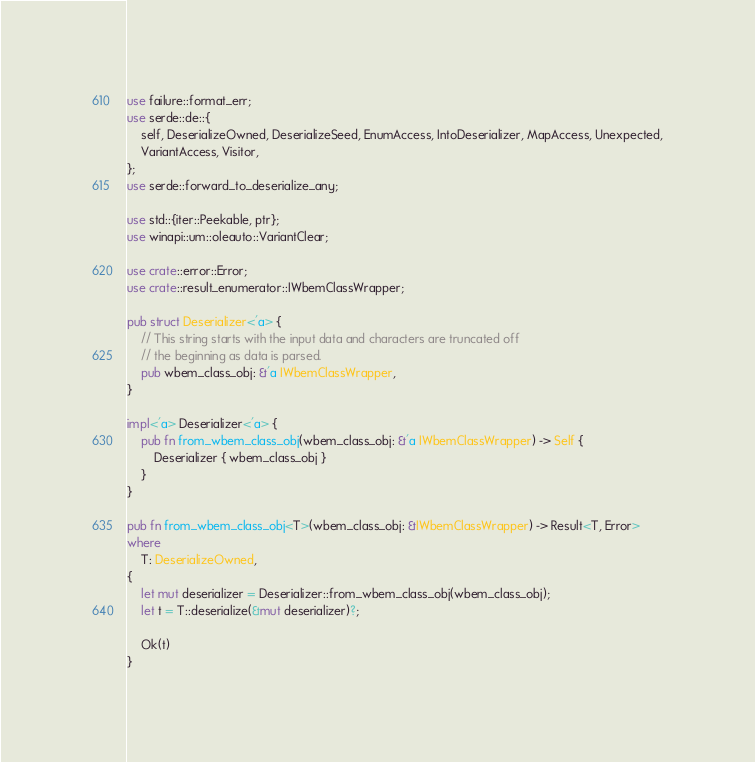<code> <loc_0><loc_0><loc_500><loc_500><_Rust_>use failure::format_err;
use serde::de::{
    self, DeserializeOwned, DeserializeSeed, EnumAccess, IntoDeserializer, MapAccess, Unexpected,
    VariantAccess, Visitor,
};
use serde::forward_to_deserialize_any;

use std::{iter::Peekable, ptr};
use winapi::um::oleauto::VariantClear;

use crate::error::Error;
use crate::result_enumerator::IWbemClassWrapper;

pub struct Deserializer<'a> {
    // This string starts with the input data and characters are truncated off
    // the beginning as data is parsed.
    pub wbem_class_obj: &'a IWbemClassWrapper,
}

impl<'a> Deserializer<'a> {
    pub fn from_wbem_class_obj(wbem_class_obj: &'a IWbemClassWrapper) -> Self {
        Deserializer { wbem_class_obj }
    }
}

pub fn from_wbem_class_obj<T>(wbem_class_obj: &IWbemClassWrapper) -> Result<T, Error>
where
    T: DeserializeOwned,
{
    let mut deserializer = Deserializer::from_wbem_class_obj(wbem_class_obj);
    let t = T::deserialize(&mut deserializer)?;

    Ok(t)
}
</code> 